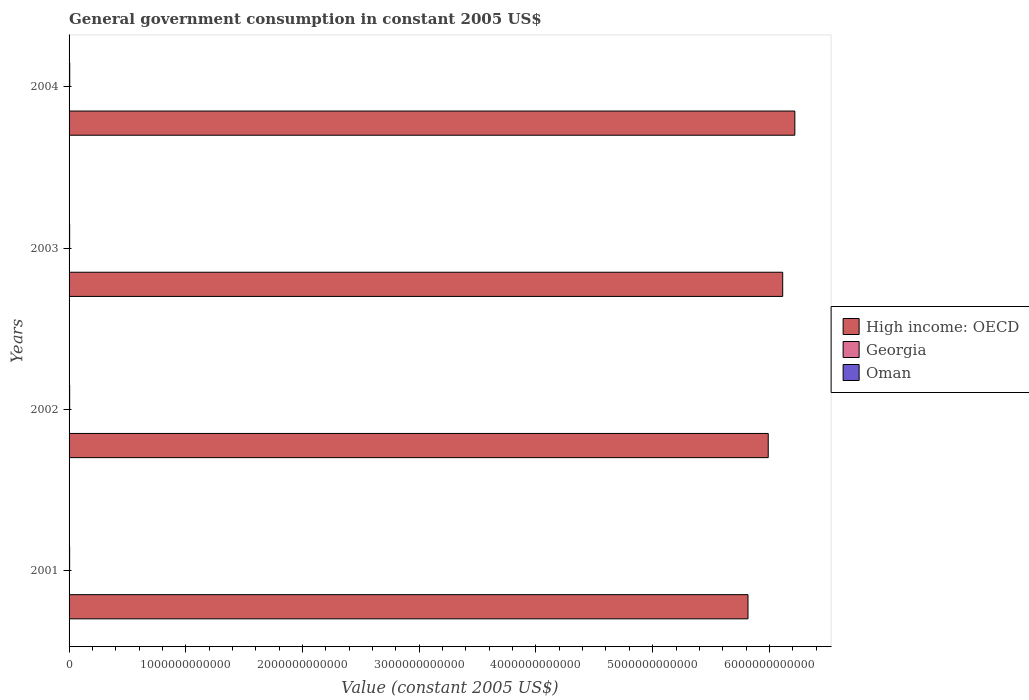How many groups of bars are there?
Make the answer very short. 4. Are the number of bars per tick equal to the number of legend labels?
Make the answer very short. Yes. Are the number of bars on each tick of the Y-axis equal?
Ensure brevity in your answer.  Yes. How many bars are there on the 2nd tick from the bottom?
Your answer should be compact. 3. What is the label of the 2nd group of bars from the top?
Give a very brief answer. 2003. In how many cases, is the number of bars for a given year not equal to the number of legend labels?
Keep it short and to the point. 0. What is the government conusmption in Georgia in 2002?
Your answer should be compact. 4.87e+08. Across all years, what is the maximum government conusmption in High income: OECD?
Provide a succinct answer. 6.22e+12. Across all years, what is the minimum government conusmption in Oman?
Offer a very short reply. 4.83e+09. In which year was the government conusmption in Oman maximum?
Ensure brevity in your answer.  2004. What is the total government conusmption in High income: OECD in the graph?
Your answer should be very brief. 2.41e+13. What is the difference between the government conusmption in High income: OECD in 2002 and that in 2003?
Your response must be concise. -1.24e+11. What is the difference between the government conusmption in Georgia in 2003 and the government conusmption in High income: OECD in 2002?
Your response must be concise. -5.99e+12. What is the average government conusmption in Oman per year?
Keep it short and to the point. 5.19e+09. In the year 2004, what is the difference between the government conusmption in High income: OECD and government conusmption in Oman?
Your response must be concise. 6.21e+12. In how many years, is the government conusmption in Oman greater than 200000000000 US$?
Your answer should be compact. 0. What is the ratio of the government conusmption in Oman in 2001 to that in 2004?
Your response must be concise. 0.84. Is the difference between the government conusmption in High income: OECD in 2001 and 2002 greater than the difference between the government conusmption in Oman in 2001 and 2002?
Provide a succinct answer. No. What is the difference between the highest and the second highest government conusmption in High income: OECD?
Offer a terse response. 1.04e+11. What is the difference between the highest and the lowest government conusmption in Georgia?
Your answer should be compact. 3.66e+08. Is the sum of the government conusmption in High income: OECD in 2002 and 2004 greater than the maximum government conusmption in Georgia across all years?
Ensure brevity in your answer.  Yes. What does the 2nd bar from the top in 2004 represents?
Offer a very short reply. Georgia. What does the 1st bar from the bottom in 2003 represents?
Your answer should be compact. High income: OECD. How many bars are there?
Your answer should be very brief. 12. What is the difference between two consecutive major ticks on the X-axis?
Your answer should be compact. 1.00e+12. Are the values on the major ticks of X-axis written in scientific E-notation?
Provide a short and direct response. No. Does the graph contain any zero values?
Ensure brevity in your answer.  No. Does the graph contain grids?
Offer a terse response. No. Where does the legend appear in the graph?
Your answer should be very brief. Center right. How many legend labels are there?
Keep it short and to the point. 3. How are the legend labels stacked?
Your response must be concise. Vertical. What is the title of the graph?
Offer a terse response. General government consumption in constant 2005 US$. Does "Congo (Democratic)" appear as one of the legend labels in the graph?
Keep it short and to the point. No. What is the label or title of the X-axis?
Offer a very short reply. Value (constant 2005 US$). What is the Value (constant 2005 US$) of High income: OECD in 2001?
Keep it short and to the point. 5.82e+12. What is the Value (constant 2005 US$) of Georgia in 2001?
Keep it short and to the point. 4.55e+08. What is the Value (constant 2005 US$) in Oman in 2001?
Ensure brevity in your answer.  4.83e+09. What is the Value (constant 2005 US$) in High income: OECD in 2002?
Offer a terse response. 5.99e+12. What is the Value (constant 2005 US$) in Georgia in 2002?
Your answer should be very brief. 4.87e+08. What is the Value (constant 2005 US$) of Oman in 2002?
Ensure brevity in your answer.  5.12e+09. What is the Value (constant 2005 US$) in High income: OECD in 2003?
Make the answer very short. 6.11e+12. What is the Value (constant 2005 US$) of Georgia in 2003?
Ensure brevity in your answer.  5.40e+08. What is the Value (constant 2005 US$) in Oman in 2003?
Your answer should be very brief. 5.08e+09. What is the Value (constant 2005 US$) in High income: OECD in 2004?
Provide a short and direct response. 6.22e+12. What is the Value (constant 2005 US$) in Georgia in 2004?
Your response must be concise. 8.21e+08. What is the Value (constant 2005 US$) of Oman in 2004?
Provide a short and direct response. 5.74e+09. Across all years, what is the maximum Value (constant 2005 US$) in High income: OECD?
Your response must be concise. 6.22e+12. Across all years, what is the maximum Value (constant 2005 US$) of Georgia?
Ensure brevity in your answer.  8.21e+08. Across all years, what is the maximum Value (constant 2005 US$) of Oman?
Keep it short and to the point. 5.74e+09. Across all years, what is the minimum Value (constant 2005 US$) in High income: OECD?
Your answer should be compact. 5.82e+12. Across all years, what is the minimum Value (constant 2005 US$) of Georgia?
Your answer should be very brief. 4.55e+08. Across all years, what is the minimum Value (constant 2005 US$) of Oman?
Provide a short and direct response. 4.83e+09. What is the total Value (constant 2005 US$) of High income: OECD in the graph?
Keep it short and to the point. 2.41e+13. What is the total Value (constant 2005 US$) of Georgia in the graph?
Give a very brief answer. 2.30e+09. What is the total Value (constant 2005 US$) of Oman in the graph?
Your response must be concise. 2.08e+1. What is the difference between the Value (constant 2005 US$) in High income: OECD in 2001 and that in 2002?
Offer a terse response. -1.73e+11. What is the difference between the Value (constant 2005 US$) in Georgia in 2001 and that in 2002?
Your answer should be compact. -3.21e+07. What is the difference between the Value (constant 2005 US$) of Oman in 2001 and that in 2002?
Offer a terse response. -2.85e+08. What is the difference between the Value (constant 2005 US$) in High income: OECD in 2001 and that in 2003?
Offer a very short reply. -2.97e+11. What is the difference between the Value (constant 2005 US$) in Georgia in 2001 and that in 2003?
Offer a terse response. -8.46e+07. What is the difference between the Value (constant 2005 US$) of Oman in 2001 and that in 2003?
Give a very brief answer. -2.44e+08. What is the difference between the Value (constant 2005 US$) of High income: OECD in 2001 and that in 2004?
Ensure brevity in your answer.  -4.01e+11. What is the difference between the Value (constant 2005 US$) of Georgia in 2001 and that in 2004?
Your response must be concise. -3.66e+08. What is the difference between the Value (constant 2005 US$) in Oman in 2001 and that in 2004?
Ensure brevity in your answer.  -9.09e+08. What is the difference between the Value (constant 2005 US$) of High income: OECD in 2002 and that in 2003?
Your answer should be compact. -1.24e+11. What is the difference between the Value (constant 2005 US$) of Georgia in 2002 and that in 2003?
Provide a succinct answer. -5.25e+07. What is the difference between the Value (constant 2005 US$) of Oman in 2002 and that in 2003?
Provide a succinct answer. 4.12e+07. What is the difference between the Value (constant 2005 US$) in High income: OECD in 2002 and that in 2004?
Make the answer very short. -2.28e+11. What is the difference between the Value (constant 2005 US$) of Georgia in 2002 and that in 2004?
Make the answer very short. -3.34e+08. What is the difference between the Value (constant 2005 US$) in Oman in 2002 and that in 2004?
Provide a short and direct response. -6.24e+08. What is the difference between the Value (constant 2005 US$) in High income: OECD in 2003 and that in 2004?
Provide a succinct answer. -1.04e+11. What is the difference between the Value (constant 2005 US$) in Georgia in 2003 and that in 2004?
Make the answer very short. -2.82e+08. What is the difference between the Value (constant 2005 US$) of Oman in 2003 and that in 2004?
Provide a short and direct response. -6.65e+08. What is the difference between the Value (constant 2005 US$) of High income: OECD in 2001 and the Value (constant 2005 US$) of Georgia in 2002?
Offer a very short reply. 5.82e+12. What is the difference between the Value (constant 2005 US$) in High income: OECD in 2001 and the Value (constant 2005 US$) in Oman in 2002?
Offer a very short reply. 5.81e+12. What is the difference between the Value (constant 2005 US$) in Georgia in 2001 and the Value (constant 2005 US$) in Oman in 2002?
Make the answer very short. -4.66e+09. What is the difference between the Value (constant 2005 US$) of High income: OECD in 2001 and the Value (constant 2005 US$) of Georgia in 2003?
Ensure brevity in your answer.  5.82e+12. What is the difference between the Value (constant 2005 US$) of High income: OECD in 2001 and the Value (constant 2005 US$) of Oman in 2003?
Offer a very short reply. 5.81e+12. What is the difference between the Value (constant 2005 US$) of Georgia in 2001 and the Value (constant 2005 US$) of Oman in 2003?
Provide a succinct answer. -4.62e+09. What is the difference between the Value (constant 2005 US$) in High income: OECD in 2001 and the Value (constant 2005 US$) in Georgia in 2004?
Ensure brevity in your answer.  5.82e+12. What is the difference between the Value (constant 2005 US$) of High income: OECD in 2001 and the Value (constant 2005 US$) of Oman in 2004?
Your answer should be compact. 5.81e+12. What is the difference between the Value (constant 2005 US$) of Georgia in 2001 and the Value (constant 2005 US$) of Oman in 2004?
Make the answer very short. -5.29e+09. What is the difference between the Value (constant 2005 US$) of High income: OECD in 2002 and the Value (constant 2005 US$) of Georgia in 2003?
Provide a succinct answer. 5.99e+12. What is the difference between the Value (constant 2005 US$) in High income: OECD in 2002 and the Value (constant 2005 US$) in Oman in 2003?
Make the answer very short. 5.98e+12. What is the difference between the Value (constant 2005 US$) in Georgia in 2002 and the Value (constant 2005 US$) in Oman in 2003?
Keep it short and to the point. -4.59e+09. What is the difference between the Value (constant 2005 US$) of High income: OECD in 2002 and the Value (constant 2005 US$) of Georgia in 2004?
Your response must be concise. 5.99e+12. What is the difference between the Value (constant 2005 US$) of High income: OECD in 2002 and the Value (constant 2005 US$) of Oman in 2004?
Ensure brevity in your answer.  5.98e+12. What is the difference between the Value (constant 2005 US$) of Georgia in 2002 and the Value (constant 2005 US$) of Oman in 2004?
Provide a succinct answer. -5.26e+09. What is the difference between the Value (constant 2005 US$) of High income: OECD in 2003 and the Value (constant 2005 US$) of Georgia in 2004?
Keep it short and to the point. 6.11e+12. What is the difference between the Value (constant 2005 US$) in High income: OECD in 2003 and the Value (constant 2005 US$) in Oman in 2004?
Make the answer very short. 6.11e+12. What is the difference between the Value (constant 2005 US$) of Georgia in 2003 and the Value (constant 2005 US$) of Oman in 2004?
Keep it short and to the point. -5.20e+09. What is the average Value (constant 2005 US$) in High income: OECD per year?
Provide a short and direct response. 6.03e+12. What is the average Value (constant 2005 US$) in Georgia per year?
Give a very brief answer. 5.76e+08. What is the average Value (constant 2005 US$) of Oman per year?
Your answer should be compact. 5.19e+09. In the year 2001, what is the difference between the Value (constant 2005 US$) in High income: OECD and Value (constant 2005 US$) in Georgia?
Ensure brevity in your answer.  5.82e+12. In the year 2001, what is the difference between the Value (constant 2005 US$) of High income: OECD and Value (constant 2005 US$) of Oman?
Make the answer very short. 5.81e+12. In the year 2001, what is the difference between the Value (constant 2005 US$) in Georgia and Value (constant 2005 US$) in Oman?
Keep it short and to the point. -4.38e+09. In the year 2002, what is the difference between the Value (constant 2005 US$) in High income: OECD and Value (constant 2005 US$) in Georgia?
Keep it short and to the point. 5.99e+12. In the year 2002, what is the difference between the Value (constant 2005 US$) of High income: OECD and Value (constant 2005 US$) of Oman?
Ensure brevity in your answer.  5.98e+12. In the year 2002, what is the difference between the Value (constant 2005 US$) of Georgia and Value (constant 2005 US$) of Oman?
Your answer should be very brief. -4.63e+09. In the year 2003, what is the difference between the Value (constant 2005 US$) in High income: OECD and Value (constant 2005 US$) in Georgia?
Your answer should be very brief. 6.11e+12. In the year 2003, what is the difference between the Value (constant 2005 US$) in High income: OECD and Value (constant 2005 US$) in Oman?
Give a very brief answer. 6.11e+12. In the year 2003, what is the difference between the Value (constant 2005 US$) in Georgia and Value (constant 2005 US$) in Oman?
Make the answer very short. -4.54e+09. In the year 2004, what is the difference between the Value (constant 2005 US$) in High income: OECD and Value (constant 2005 US$) in Georgia?
Make the answer very short. 6.22e+12. In the year 2004, what is the difference between the Value (constant 2005 US$) of High income: OECD and Value (constant 2005 US$) of Oman?
Provide a short and direct response. 6.21e+12. In the year 2004, what is the difference between the Value (constant 2005 US$) of Georgia and Value (constant 2005 US$) of Oman?
Ensure brevity in your answer.  -4.92e+09. What is the ratio of the Value (constant 2005 US$) of High income: OECD in 2001 to that in 2002?
Make the answer very short. 0.97. What is the ratio of the Value (constant 2005 US$) of Georgia in 2001 to that in 2002?
Give a very brief answer. 0.93. What is the ratio of the Value (constant 2005 US$) in Oman in 2001 to that in 2002?
Keep it short and to the point. 0.94. What is the ratio of the Value (constant 2005 US$) in High income: OECD in 2001 to that in 2003?
Give a very brief answer. 0.95. What is the ratio of the Value (constant 2005 US$) in Georgia in 2001 to that in 2003?
Offer a terse response. 0.84. What is the ratio of the Value (constant 2005 US$) of Oman in 2001 to that in 2003?
Your answer should be very brief. 0.95. What is the ratio of the Value (constant 2005 US$) in High income: OECD in 2001 to that in 2004?
Offer a very short reply. 0.94. What is the ratio of the Value (constant 2005 US$) in Georgia in 2001 to that in 2004?
Offer a terse response. 0.55. What is the ratio of the Value (constant 2005 US$) in Oman in 2001 to that in 2004?
Keep it short and to the point. 0.84. What is the ratio of the Value (constant 2005 US$) in High income: OECD in 2002 to that in 2003?
Offer a very short reply. 0.98. What is the ratio of the Value (constant 2005 US$) of Georgia in 2002 to that in 2003?
Your response must be concise. 0.9. What is the ratio of the Value (constant 2005 US$) of High income: OECD in 2002 to that in 2004?
Provide a succinct answer. 0.96. What is the ratio of the Value (constant 2005 US$) of Georgia in 2002 to that in 2004?
Provide a short and direct response. 0.59. What is the ratio of the Value (constant 2005 US$) of Oman in 2002 to that in 2004?
Your answer should be compact. 0.89. What is the ratio of the Value (constant 2005 US$) in High income: OECD in 2003 to that in 2004?
Provide a succinct answer. 0.98. What is the ratio of the Value (constant 2005 US$) of Georgia in 2003 to that in 2004?
Give a very brief answer. 0.66. What is the ratio of the Value (constant 2005 US$) of Oman in 2003 to that in 2004?
Provide a succinct answer. 0.88. What is the difference between the highest and the second highest Value (constant 2005 US$) in High income: OECD?
Provide a succinct answer. 1.04e+11. What is the difference between the highest and the second highest Value (constant 2005 US$) of Georgia?
Offer a very short reply. 2.82e+08. What is the difference between the highest and the second highest Value (constant 2005 US$) in Oman?
Give a very brief answer. 6.24e+08. What is the difference between the highest and the lowest Value (constant 2005 US$) of High income: OECD?
Give a very brief answer. 4.01e+11. What is the difference between the highest and the lowest Value (constant 2005 US$) of Georgia?
Your answer should be very brief. 3.66e+08. What is the difference between the highest and the lowest Value (constant 2005 US$) in Oman?
Your response must be concise. 9.09e+08. 